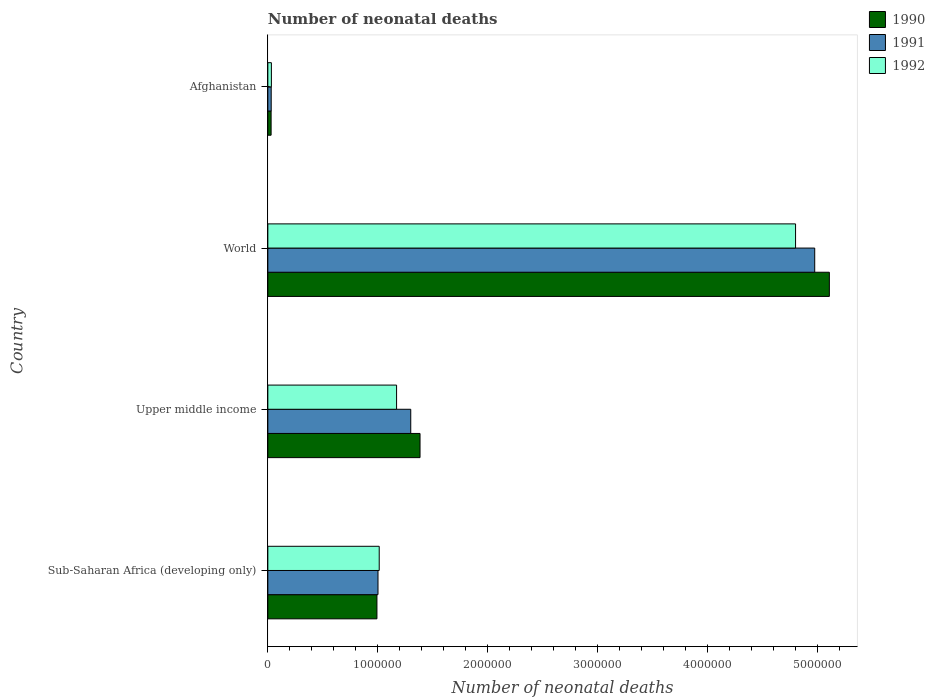How many different coloured bars are there?
Ensure brevity in your answer.  3. How many groups of bars are there?
Your answer should be compact. 4. What is the label of the 1st group of bars from the top?
Your answer should be compact. Afghanistan. What is the number of neonatal deaths in in 1992 in Sub-Saharan Africa (developing only)?
Ensure brevity in your answer.  1.01e+06. Across all countries, what is the maximum number of neonatal deaths in in 1991?
Your answer should be very brief. 4.97e+06. Across all countries, what is the minimum number of neonatal deaths in in 1991?
Provide a short and direct response. 3.05e+04. In which country was the number of neonatal deaths in in 1991 minimum?
Your answer should be very brief. Afghanistan. What is the total number of neonatal deaths in in 1990 in the graph?
Give a very brief answer. 7.51e+06. What is the difference between the number of neonatal deaths in in 1992 in Afghanistan and that in World?
Offer a very short reply. -4.77e+06. What is the difference between the number of neonatal deaths in in 1991 in Sub-Saharan Africa (developing only) and the number of neonatal deaths in in 1990 in Afghanistan?
Offer a terse response. 9.72e+05. What is the average number of neonatal deaths in in 1992 per country?
Your answer should be compact. 1.75e+06. What is the difference between the number of neonatal deaths in in 1990 and number of neonatal deaths in in 1992 in Upper middle income?
Ensure brevity in your answer.  2.13e+05. In how many countries, is the number of neonatal deaths in in 1992 greater than 1600000 ?
Your answer should be very brief. 1. What is the ratio of the number of neonatal deaths in in 1992 in Afghanistan to that in Upper middle income?
Your response must be concise. 0.03. What is the difference between the highest and the second highest number of neonatal deaths in in 1991?
Your answer should be compact. 3.67e+06. What is the difference between the highest and the lowest number of neonatal deaths in in 1991?
Your answer should be compact. 4.94e+06. In how many countries, is the number of neonatal deaths in in 1990 greater than the average number of neonatal deaths in in 1990 taken over all countries?
Make the answer very short. 1. What does the 1st bar from the top in Afghanistan represents?
Provide a succinct answer. 1992. What does the 3rd bar from the bottom in Upper middle income represents?
Offer a terse response. 1992. How many countries are there in the graph?
Ensure brevity in your answer.  4. What is the difference between two consecutive major ticks on the X-axis?
Your response must be concise. 1.00e+06. Does the graph contain any zero values?
Provide a short and direct response. No. Does the graph contain grids?
Make the answer very short. No. Where does the legend appear in the graph?
Provide a short and direct response. Top right. How are the legend labels stacked?
Your response must be concise. Vertical. What is the title of the graph?
Provide a short and direct response. Number of neonatal deaths. What is the label or title of the X-axis?
Your answer should be very brief. Number of neonatal deaths. What is the Number of neonatal deaths of 1990 in Sub-Saharan Africa (developing only)?
Ensure brevity in your answer.  9.92e+05. What is the Number of neonatal deaths of 1991 in Sub-Saharan Africa (developing only)?
Ensure brevity in your answer.  1.00e+06. What is the Number of neonatal deaths of 1992 in Sub-Saharan Africa (developing only)?
Your answer should be compact. 1.01e+06. What is the Number of neonatal deaths of 1990 in Upper middle income?
Offer a terse response. 1.38e+06. What is the Number of neonatal deaths of 1991 in Upper middle income?
Offer a terse response. 1.30e+06. What is the Number of neonatal deaths of 1992 in Upper middle income?
Keep it short and to the point. 1.17e+06. What is the Number of neonatal deaths in 1990 in World?
Ensure brevity in your answer.  5.11e+06. What is the Number of neonatal deaths of 1991 in World?
Offer a very short reply. 4.97e+06. What is the Number of neonatal deaths in 1992 in World?
Provide a short and direct response. 4.80e+06. What is the Number of neonatal deaths in 1990 in Afghanistan?
Offer a terse response. 2.97e+04. What is the Number of neonatal deaths in 1991 in Afghanistan?
Offer a very short reply. 3.05e+04. What is the Number of neonatal deaths of 1992 in Afghanistan?
Offer a terse response. 3.23e+04. Across all countries, what is the maximum Number of neonatal deaths in 1990?
Provide a short and direct response. 5.11e+06. Across all countries, what is the maximum Number of neonatal deaths in 1991?
Your response must be concise. 4.97e+06. Across all countries, what is the maximum Number of neonatal deaths in 1992?
Offer a very short reply. 4.80e+06. Across all countries, what is the minimum Number of neonatal deaths in 1990?
Give a very brief answer. 2.97e+04. Across all countries, what is the minimum Number of neonatal deaths in 1991?
Offer a terse response. 3.05e+04. Across all countries, what is the minimum Number of neonatal deaths of 1992?
Offer a terse response. 3.23e+04. What is the total Number of neonatal deaths in 1990 in the graph?
Provide a succinct answer. 7.51e+06. What is the total Number of neonatal deaths in 1991 in the graph?
Make the answer very short. 7.30e+06. What is the total Number of neonatal deaths in 1992 in the graph?
Offer a very short reply. 7.01e+06. What is the difference between the Number of neonatal deaths in 1990 in Sub-Saharan Africa (developing only) and that in Upper middle income?
Your answer should be very brief. -3.92e+05. What is the difference between the Number of neonatal deaths of 1991 in Sub-Saharan Africa (developing only) and that in Upper middle income?
Keep it short and to the point. -2.98e+05. What is the difference between the Number of neonatal deaths of 1992 in Sub-Saharan Africa (developing only) and that in Upper middle income?
Make the answer very short. -1.58e+05. What is the difference between the Number of neonatal deaths in 1990 in Sub-Saharan Africa (developing only) and that in World?
Offer a terse response. -4.11e+06. What is the difference between the Number of neonatal deaths of 1991 in Sub-Saharan Africa (developing only) and that in World?
Keep it short and to the point. -3.97e+06. What is the difference between the Number of neonatal deaths of 1992 in Sub-Saharan Africa (developing only) and that in World?
Ensure brevity in your answer.  -3.79e+06. What is the difference between the Number of neonatal deaths of 1990 in Sub-Saharan Africa (developing only) and that in Afghanistan?
Make the answer very short. 9.62e+05. What is the difference between the Number of neonatal deaths of 1991 in Sub-Saharan Africa (developing only) and that in Afghanistan?
Offer a terse response. 9.71e+05. What is the difference between the Number of neonatal deaths of 1992 in Sub-Saharan Africa (developing only) and that in Afghanistan?
Provide a short and direct response. 9.81e+05. What is the difference between the Number of neonatal deaths in 1990 in Upper middle income and that in World?
Offer a terse response. -3.72e+06. What is the difference between the Number of neonatal deaths in 1991 in Upper middle income and that in World?
Give a very brief answer. -3.67e+06. What is the difference between the Number of neonatal deaths of 1992 in Upper middle income and that in World?
Your answer should be very brief. -3.63e+06. What is the difference between the Number of neonatal deaths in 1990 in Upper middle income and that in Afghanistan?
Make the answer very short. 1.35e+06. What is the difference between the Number of neonatal deaths in 1991 in Upper middle income and that in Afghanistan?
Ensure brevity in your answer.  1.27e+06. What is the difference between the Number of neonatal deaths of 1992 in Upper middle income and that in Afghanistan?
Keep it short and to the point. 1.14e+06. What is the difference between the Number of neonatal deaths in 1990 in World and that in Afghanistan?
Provide a succinct answer. 5.08e+06. What is the difference between the Number of neonatal deaths of 1991 in World and that in Afghanistan?
Provide a succinct answer. 4.94e+06. What is the difference between the Number of neonatal deaths in 1992 in World and that in Afghanistan?
Your response must be concise. 4.77e+06. What is the difference between the Number of neonatal deaths of 1990 in Sub-Saharan Africa (developing only) and the Number of neonatal deaths of 1991 in Upper middle income?
Offer a terse response. -3.08e+05. What is the difference between the Number of neonatal deaths in 1990 in Sub-Saharan Africa (developing only) and the Number of neonatal deaths in 1992 in Upper middle income?
Provide a short and direct response. -1.79e+05. What is the difference between the Number of neonatal deaths in 1991 in Sub-Saharan Africa (developing only) and the Number of neonatal deaths in 1992 in Upper middle income?
Your response must be concise. -1.69e+05. What is the difference between the Number of neonatal deaths in 1990 in Sub-Saharan Africa (developing only) and the Number of neonatal deaths in 1991 in World?
Give a very brief answer. -3.98e+06. What is the difference between the Number of neonatal deaths in 1990 in Sub-Saharan Africa (developing only) and the Number of neonatal deaths in 1992 in World?
Ensure brevity in your answer.  -3.81e+06. What is the difference between the Number of neonatal deaths of 1991 in Sub-Saharan Africa (developing only) and the Number of neonatal deaths of 1992 in World?
Your response must be concise. -3.80e+06. What is the difference between the Number of neonatal deaths of 1990 in Sub-Saharan Africa (developing only) and the Number of neonatal deaths of 1991 in Afghanistan?
Your response must be concise. 9.61e+05. What is the difference between the Number of neonatal deaths of 1990 in Sub-Saharan Africa (developing only) and the Number of neonatal deaths of 1992 in Afghanistan?
Ensure brevity in your answer.  9.60e+05. What is the difference between the Number of neonatal deaths in 1991 in Sub-Saharan Africa (developing only) and the Number of neonatal deaths in 1992 in Afghanistan?
Your response must be concise. 9.69e+05. What is the difference between the Number of neonatal deaths in 1990 in Upper middle income and the Number of neonatal deaths in 1991 in World?
Your response must be concise. -3.59e+06. What is the difference between the Number of neonatal deaths of 1990 in Upper middle income and the Number of neonatal deaths of 1992 in World?
Offer a terse response. -3.41e+06. What is the difference between the Number of neonatal deaths of 1991 in Upper middle income and the Number of neonatal deaths of 1992 in World?
Ensure brevity in your answer.  -3.50e+06. What is the difference between the Number of neonatal deaths of 1990 in Upper middle income and the Number of neonatal deaths of 1991 in Afghanistan?
Your answer should be compact. 1.35e+06. What is the difference between the Number of neonatal deaths of 1990 in Upper middle income and the Number of neonatal deaths of 1992 in Afghanistan?
Your response must be concise. 1.35e+06. What is the difference between the Number of neonatal deaths in 1991 in Upper middle income and the Number of neonatal deaths in 1992 in Afghanistan?
Keep it short and to the point. 1.27e+06. What is the difference between the Number of neonatal deaths of 1990 in World and the Number of neonatal deaths of 1991 in Afghanistan?
Your answer should be very brief. 5.08e+06. What is the difference between the Number of neonatal deaths in 1990 in World and the Number of neonatal deaths in 1992 in Afghanistan?
Offer a terse response. 5.07e+06. What is the difference between the Number of neonatal deaths in 1991 in World and the Number of neonatal deaths in 1992 in Afghanistan?
Provide a short and direct response. 4.94e+06. What is the average Number of neonatal deaths of 1990 per country?
Your answer should be compact. 1.88e+06. What is the average Number of neonatal deaths in 1991 per country?
Make the answer very short. 1.83e+06. What is the average Number of neonatal deaths of 1992 per country?
Provide a succinct answer. 1.75e+06. What is the difference between the Number of neonatal deaths of 1990 and Number of neonatal deaths of 1991 in Sub-Saharan Africa (developing only)?
Your answer should be compact. -9692. What is the difference between the Number of neonatal deaths of 1990 and Number of neonatal deaths of 1992 in Sub-Saharan Africa (developing only)?
Your answer should be very brief. -2.08e+04. What is the difference between the Number of neonatal deaths in 1991 and Number of neonatal deaths in 1992 in Sub-Saharan Africa (developing only)?
Provide a short and direct response. -1.11e+04. What is the difference between the Number of neonatal deaths of 1990 and Number of neonatal deaths of 1991 in Upper middle income?
Keep it short and to the point. 8.45e+04. What is the difference between the Number of neonatal deaths in 1990 and Number of neonatal deaths in 1992 in Upper middle income?
Your response must be concise. 2.13e+05. What is the difference between the Number of neonatal deaths of 1991 and Number of neonatal deaths of 1992 in Upper middle income?
Your answer should be very brief. 1.29e+05. What is the difference between the Number of neonatal deaths of 1990 and Number of neonatal deaths of 1991 in World?
Provide a succinct answer. 1.33e+05. What is the difference between the Number of neonatal deaths in 1990 and Number of neonatal deaths in 1992 in World?
Your response must be concise. 3.07e+05. What is the difference between the Number of neonatal deaths in 1991 and Number of neonatal deaths in 1992 in World?
Your answer should be very brief. 1.74e+05. What is the difference between the Number of neonatal deaths in 1990 and Number of neonatal deaths in 1991 in Afghanistan?
Keep it short and to the point. -879. What is the difference between the Number of neonatal deaths of 1990 and Number of neonatal deaths of 1992 in Afghanistan?
Make the answer very short. -2612. What is the difference between the Number of neonatal deaths of 1991 and Number of neonatal deaths of 1992 in Afghanistan?
Provide a succinct answer. -1733. What is the ratio of the Number of neonatal deaths of 1990 in Sub-Saharan Africa (developing only) to that in Upper middle income?
Make the answer very short. 0.72. What is the ratio of the Number of neonatal deaths of 1991 in Sub-Saharan Africa (developing only) to that in Upper middle income?
Provide a short and direct response. 0.77. What is the ratio of the Number of neonatal deaths in 1992 in Sub-Saharan Africa (developing only) to that in Upper middle income?
Give a very brief answer. 0.87. What is the ratio of the Number of neonatal deaths of 1990 in Sub-Saharan Africa (developing only) to that in World?
Make the answer very short. 0.19. What is the ratio of the Number of neonatal deaths in 1991 in Sub-Saharan Africa (developing only) to that in World?
Provide a short and direct response. 0.2. What is the ratio of the Number of neonatal deaths in 1992 in Sub-Saharan Africa (developing only) to that in World?
Provide a succinct answer. 0.21. What is the ratio of the Number of neonatal deaths in 1990 in Sub-Saharan Africa (developing only) to that in Afghanistan?
Offer a very short reply. 33.45. What is the ratio of the Number of neonatal deaths in 1991 in Sub-Saharan Africa (developing only) to that in Afghanistan?
Your answer should be very brief. 32.8. What is the ratio of the Number of neonatal deaths of 1992 in Sub-Saharan Africa (developing only) to that in Afghanistan?
Keep it short and to the point. 31.39. What is the ratio of the Number of neonatal deaths of 1990 in Upper middle income to that in World?
Keep it short and to the point. 0.27. What is the ratio of the Number of neonatal deaths of 1991 in Upper middle income to that in World?
Your response must be concise. 0.26. What is the ratio of the Number of neonatal deaths in 1992 in Upper middle income to that in World?
Provide a short and direct response. 0.24. What is the ratio of the Number of neonatal deaths of 1990 in Upper middle income to that in Afghanistan?
Your response must be concise. 46.66. What is the ratio of the Number of neonatal deaths of 1991 in Upper middle income to that in Afghanistan?
Your answer should be compact. 42.56. What is the ratio of the Number of neonatal deaths in 1992 in Upper middle income to that in Afghanistan?
Offer a terse response. 36.28. What is the ratio of the Number of neonatal deaths in 1990 in World to that in Afghanistan?
Give a very brief answer. 172.17. What is the ratio of the Number of neonatal deaths in 1991 in World to that in Afghanistan?
Your answer should be very brief. 162.86. What is the ratio of the Number of neonatal deaths of 1992 in World to that in Afghanistan?
Your response must be concise. 148.71. What is the difference between the highest and the second highest Number of neonatal deaths in 1990?
Offer a terse response. 3.72e+06. What is the difference between the highest and the second highest Number of neonatal deaths of 1991?
Make the answer very short. 3.67e+06. What is the difference between the highest and the second highest Number of neonatal deaths of 1992?
Provide a succinct answer. 3.63e+06. What is the difference between the highest and the lowest Number of neonatal deaths in 1990?
Offer a very short reply. 5.08e+06. What is the difference between the highest and the lowest Number of neonatal deaths in 1991?
Keep it short and to the point. 4.94e+06. What is the difference between the highest and the lowest Number of neonatal deaths of 1992?
Offer a terse response. 4.77e+06. 